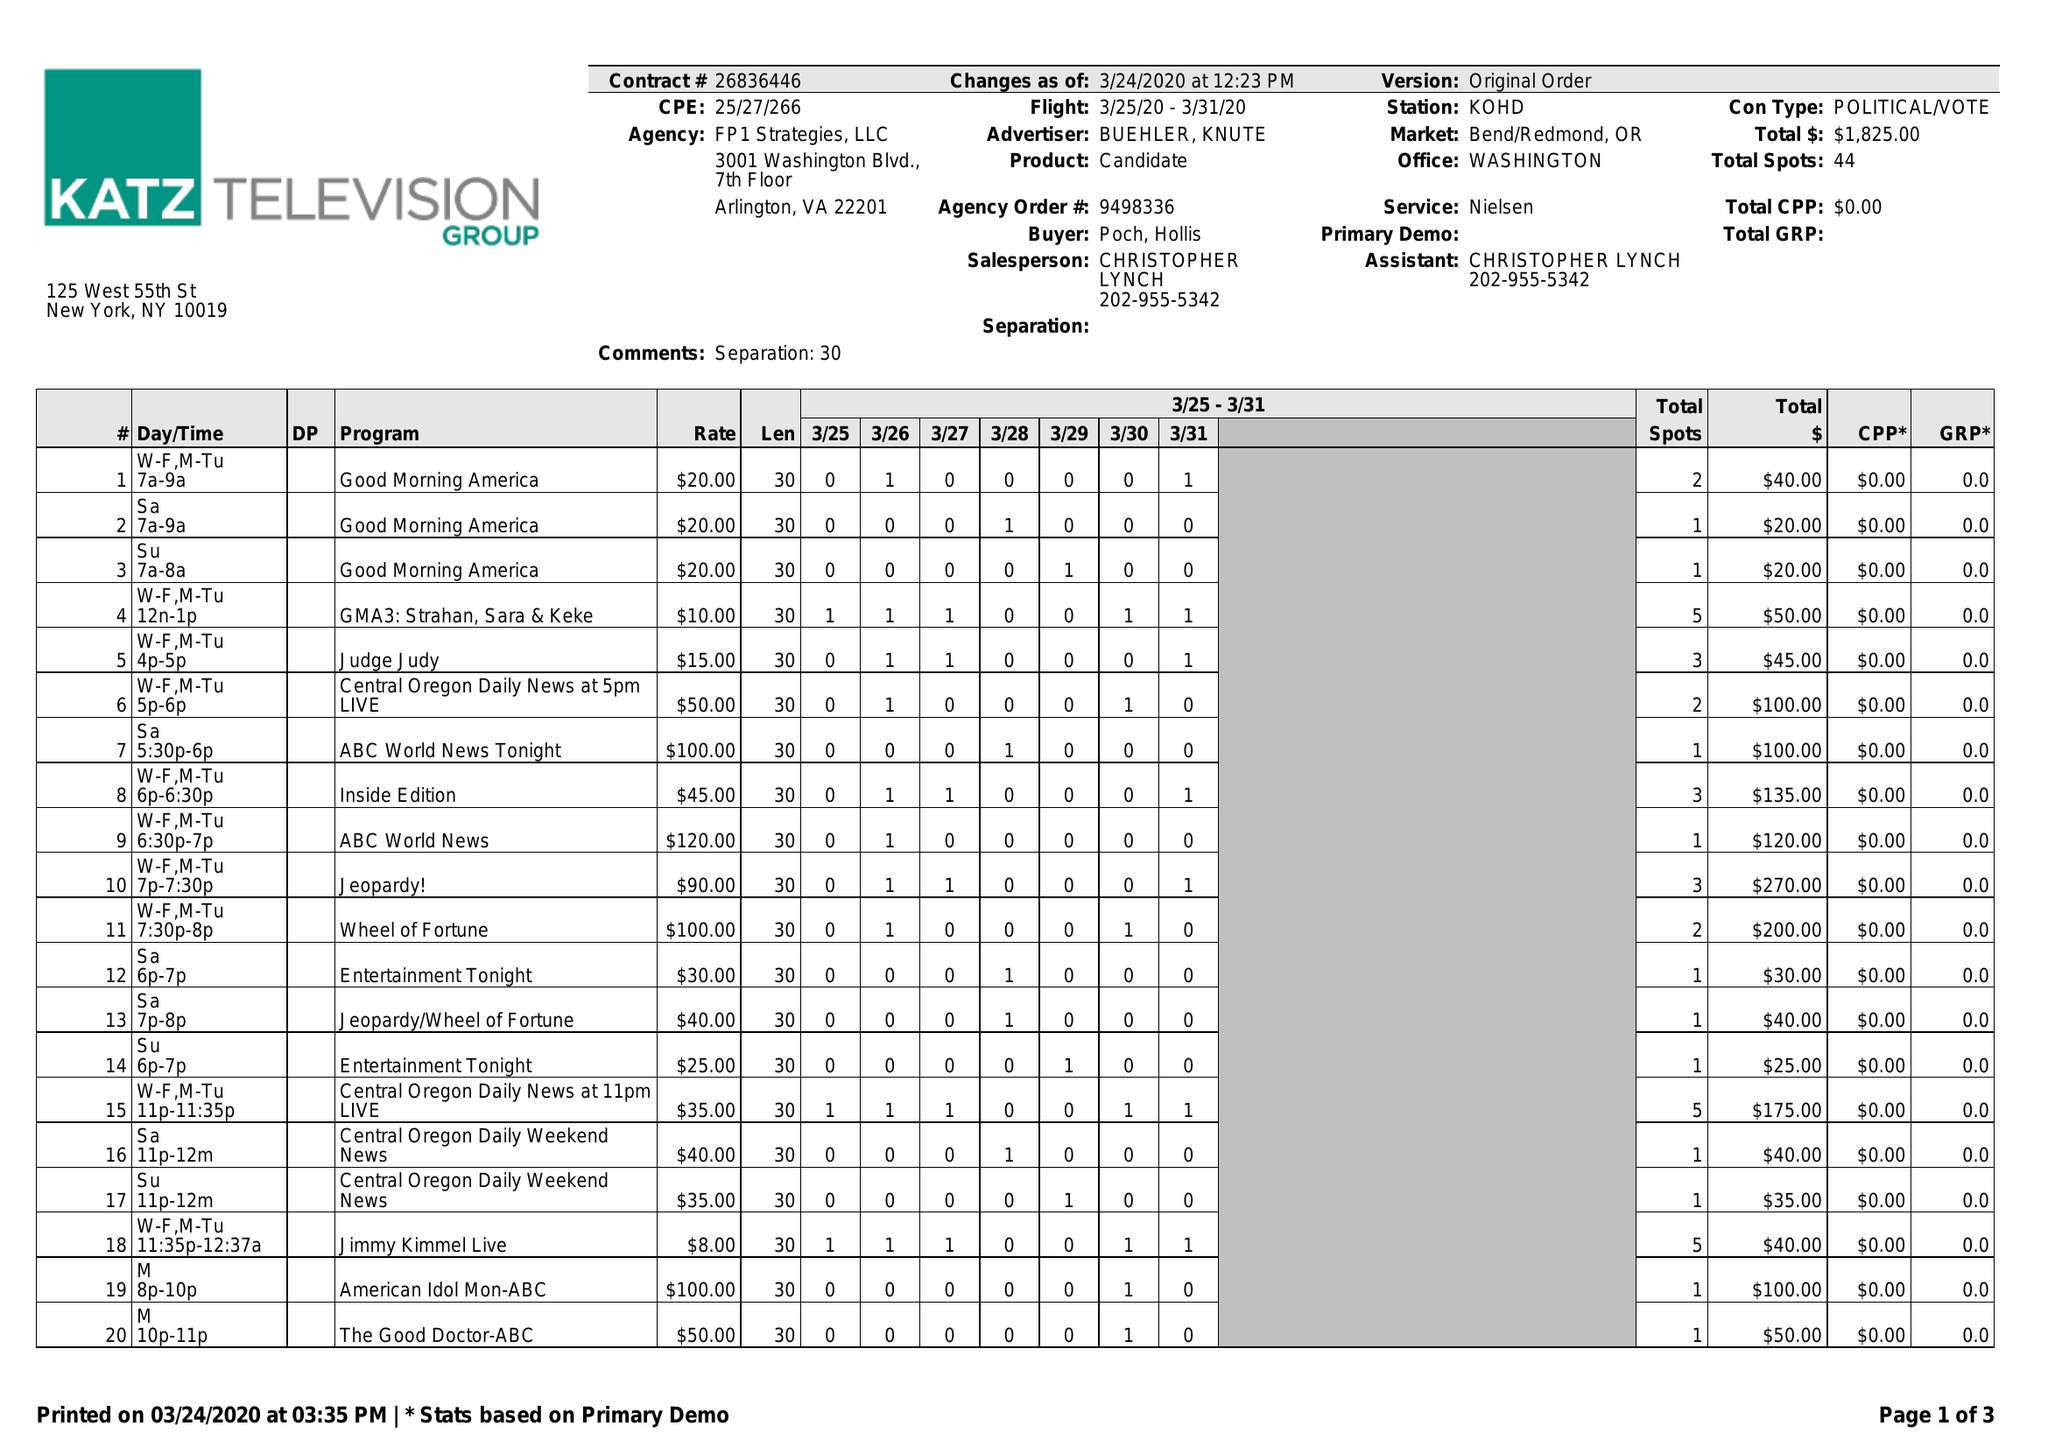What is the value for the flight_from?
Answer the question using a single word or phrase. 03/25/20 